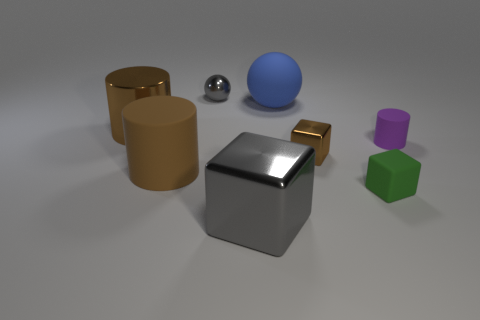How many blue objects are either rubber spheres or small metal spheres?
Your answer should be compact. 1. What size is the block to the right of the tiny metal object that is in front of the large blue thing?
Give a very brief answer. Small. There is a green object that is the same shape as the large gray metal thing; what material is it?
Ensure brevity in your answer.  Rubber. How many metal things have the same size as the brown rubber cylinder?
Keep it short and to the point. 2. Do the matte block and the rubber ball have the same size?
Provide a short and direct response. No. What size is the object that is both behind the large matte cylinder and right of the brown cube?
Keep it short and to the point. Small. Are there more small purple things in front of the large blue rubber sphere than tiny purple matte things that are on the left side of the tiny brown block?
Provide a succinct answer. Yes. There is a metallic object that is the same shape as the big brown matte object; what color is it?
Provide a short and direct response. Brown. There is a large shiny object that is in front of the tiny purple object; is its color the same as the large ball?
Provide a succinct answer. No. What number of brown metal cylinders are there?
Offer a very short reply. 1. 